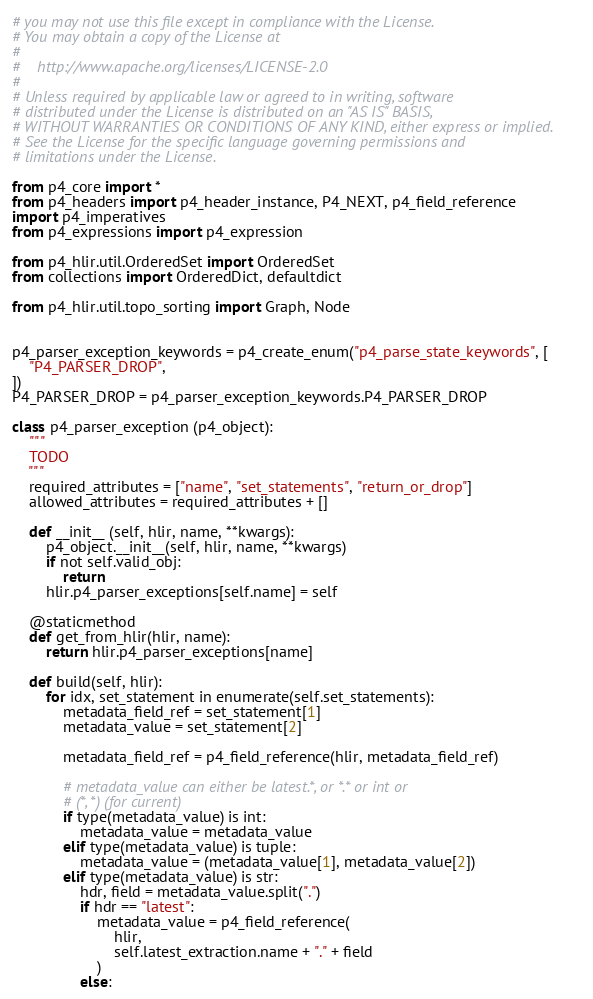<code> <loc_0><loc_0><loc_500><loc_500><_Python_># you may not use this file except in compliance with the License.
# You may obtain a copy of the License at
# 
#    http://www.apache.org/licenses/LICENSE-2.0
#
# Unless required by applicable law or agreed to in writing, software
# distributed under the License is distributed on an "AS IS" BASIS,
# WITHOUT WARRANTIES OR CONDITIONS OF ANY KIND, either express or implied.
# See the License for the specific language governing permissions and
# limitations under the License.

from p4_core import *
from p4_headers import p4_header_instance, P4_NEXT, p4_field_reference
import p4_imperatives
from p4_expressions import p4_expression

from p4_hlir.util.OrderedSet import OrderedSet
from collections import OrderedDict, defaultdict

from p4_hlir.util.topo_sorting import Graph, Node


p4_parser_exception_keywords = p4_create_enum("p4_parse_state_keywords", [
    "P4_PARSER_DROP",
])
P4_PARSER_DROP = p4_parser_exception_keywords.P4_PARSER_DROP

class p4_parser_exception (p4_object):
    """
    TODO
    """
    required_attributes = ["name", "set_statements", "return_or_drop"]
    allowed_attributes = required_attributes + []

    def __init__ (self, hlir, name, **kwargs):
        p4_object.__init__(self, hlir, name, **kwargs)
        if not self.valid_obj:
            return 
        hlir.p4_parser_exceptions[self.name] = self

    @staticmethod
    def get_from_hlir(hlir, name):
        return hlir.p4_parser_exceptions[name]

    def build(self, hlir):
        for idx, set_statement in enumerate(self.set_statements):
            metadata_field_ref = set_statement[1]
            metadata_value = set_statement[2]
                
            metadata_field_ref = p4_field_reference(hlir, metadata_field_ref)
                
            # metadata_value can either be latest.*, or *.* or int or
            # (*, *) (for current)
            if type(metadata_value) is int:
                metadata_value = metadata_value
            elif type(metadata_value) is tuple:
                metadata_value = (metadata_value[1], metadata_value[2])
            elif type(metadata_value) is str:
                hdr, field = metadata_value.split(".")
                if hdr == "latest":
                    metadata_value = p4_field_reference(
                        hlir, 
                        self.latest_extraction.name + "." + field
                    )
                else:</code> 